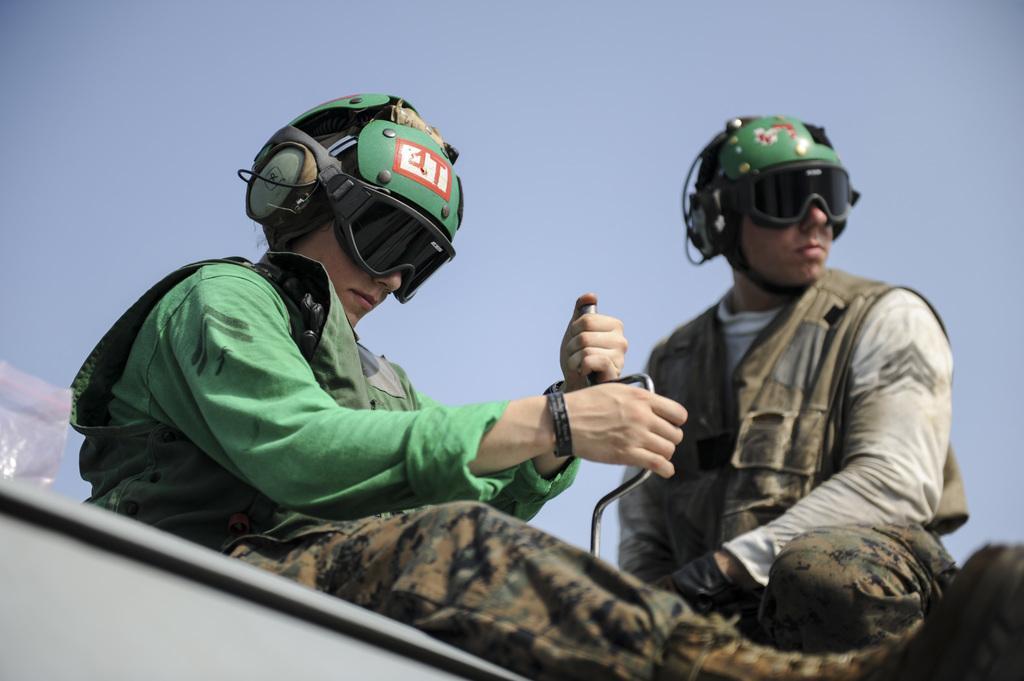Please provide a concise description of this image. In this image we can see two persons and the persons are wearing helmets. Among them a person is holding an object. In the bottom left we can see an object. At the top we can see the sky. 